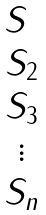<formula> <loc_0><loc_0><loc_500><loc_500>\begin{matrix} S \ \\ S _ { 2 } \\ S _ { 3 } \\ \vdots \\ S _ { n } \end{matrix}</formula> 